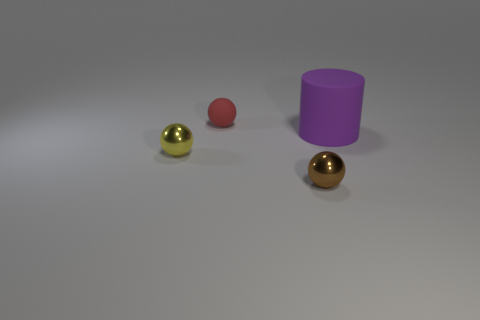What is the color of the object that is in front of the big matte cylinder and behind the tiny brown metal ball?
Your answer should be compact. Yellow. How big is the rubber object that is on the right side of the tiny shiny thing to the right of the tiny metal thing on the left side of the small red matte thing?
Offer a terse response. Large. What number of objects are small things that are behind the large purple rubber thing or metal balls that are on the right side of the red matte object?
Your response must be concise. 2. What shape is the purple thing?
Your response must be concise. Cylinder. There is a red rubber object that is the same shape as the tiny yellow thing; what is its size?
Keep it short and to the point. Small. There is a thing in front of the tiny yellow metal sphere on the left side of the small thing that is behind the big purple thing; what is it made of?
Make the answer very short. Metal. Are there any small metallic balls?
Your answer should be very brief. Yes. There is a large cylinder; is it the same color as the small metallic thing that is left of the tiny red ball?
Give a very brief answer. No. The tiny matte thing has what color?
Provide a succinct answer. Red. Are there any other things that have the same shape as the small yellow metal thing?
Your response must be concise. Yes. 